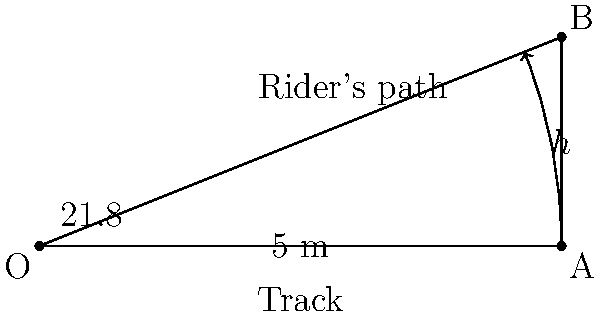At a speedway track, a rider approaches a sharp turn. The optimal path forms a 21.8° angle with the straight part of the track, creating a right triangle. If the straight distance to the turn is 5 meters, what is the height ($h$) of the triangle formed by the rider's optimal path? Round your answer to two decimal places. To solve this problem, we'll use trigonometry, specifically the sine function. Let's break it down step-by-step:

1) In a right triangle, sine of an angle is the ratio of the opposite side to the hypotenuse.

2) In this case:
   - The angle is 21.8°
   - The hypotenuse is 5 meters (the straight distance to the turn)
   - We need to find the opposite side ($h$)

3) We can express this relationship as:

   $\sin(21.8°) = \frac{h}{5}$

4) To find $h$, we multiply both sides by 5:

   $h = 5 \times \sin(21.8°)$

5) Now, let's calculate:
   
   $h = 5 \times \sin(21.8°)$
   $h = 5 \times 0.3716$ (using a calculator)
   $h = 1.858$ meters

6) Rounding to two decimal places:

   $h \approx 1.86$ meters

Therefore, the height of the triangle formed by the rider's optimal path is approximately 1.86 meters.
Answer: 1.86 m 